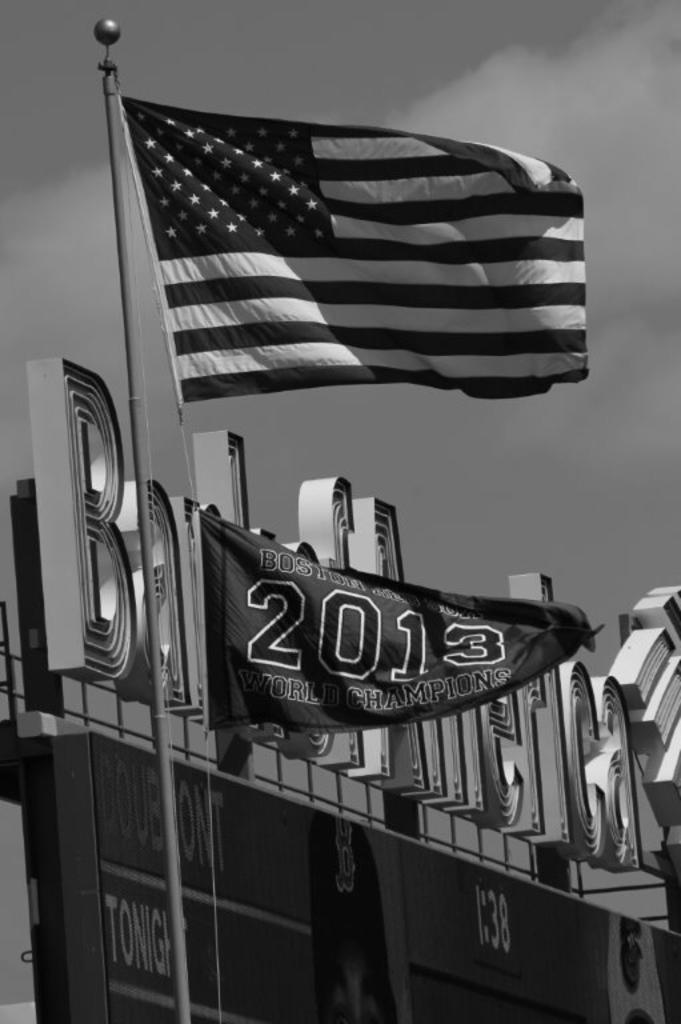Provide a one-sentence caption for the provided image. On the pole beneath the American flag is another stating Boston team was the 2013 champion. 